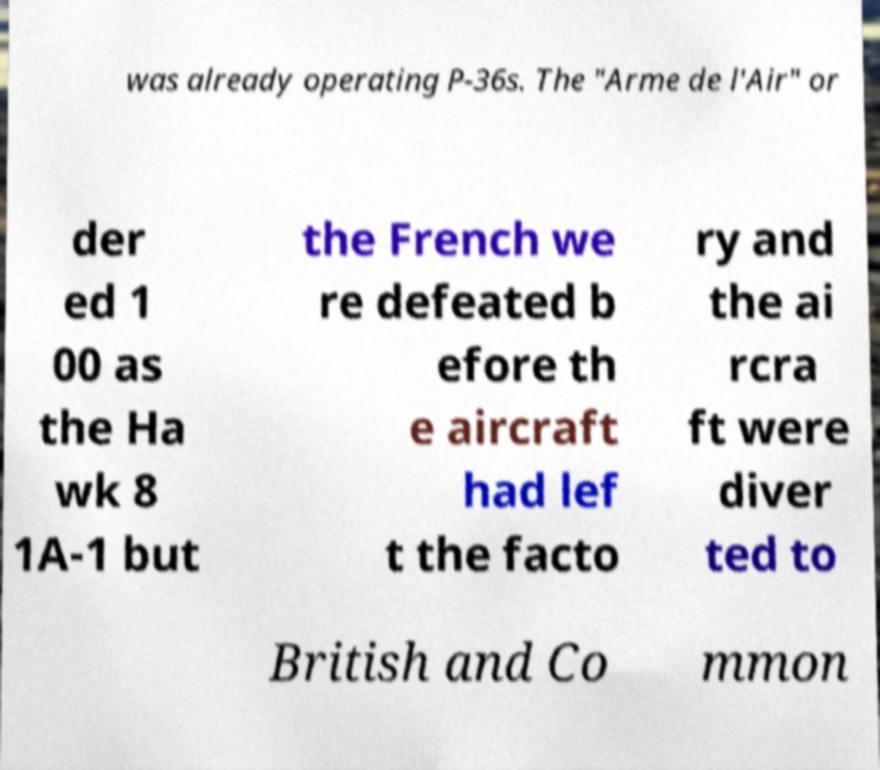Can you read and provide the text displayed in the image?This photo seems to have some interesting text. Can you extract and type it out for me? was already operating P-36s. The "Arme de l'Air" or der ed 1 00 as the Ha wk 8 1A-1 but the French we re defeated b efore th e aircraft had lef t the facto ry and the ai rcra ft were diver ted to British and Co mmon 